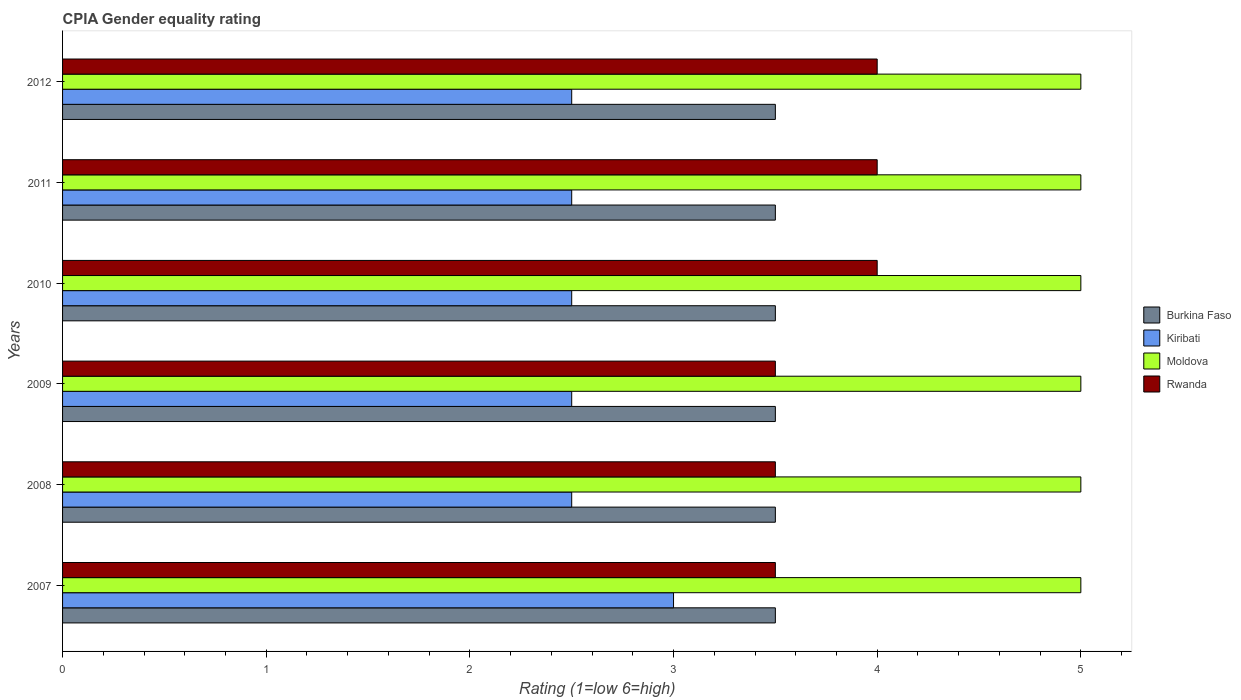How many different coloured bars are there?
Keep it short and to the point. 4. How many bars are there on the 1st tick from the top?
Offer a very short reply. 4. How many bars are there on the 5th tick from the bottom?
Make the answer very short. 4. What is the label of the 1st group of bars from the top?
Give a very brief answer. 2012. What is the CPIA rating in Burkina Faso in 2008?
Provide a short and direct response. 3.5. Across all years, what is the maximum CPIA rating in Kiribati?
Offer a very short reply. 3. Across all years, what is the minimum CPIA rating in Kiribati?
Make the answer very short. 2.5. In which year was the CPIA rating in Burkina Faso minimum?
Keep it short and to the point. 2007. What is the total CPIA rating in Rwanda in the graph?
Offer a very short reply. 22.5. What is the difference between the CPIA rating in Rwanda in 2009 and the CPIA rating in Burkina Faso in 2011?
Provide a short and direct response. 0. In the year 2007, what is the difference between the CPIA rating in Moldova and CPIA rating in Kiribati?
Your answer should be very brief. 2. In how many years, is the CPIA rating in Moldova greater than 3.2 ?
Your answer should be compact. 6. What is the ratio of the CPIA rating in Kiribati in 2009 to that in 2011?
Give a very brief answer. 1. What is the difference between the highest and the second highest CPIA rating in Rwanda?
Provide a short and direct response. 0. What is the difference between the highest and the lowest CPIA rating in Moldova?
Make the answer very short. 0. Is it the case that in every year, the sum of the CPIA rating in Burkina Faso and CPIA rating in Rwanda is greater than the sum of CPIA rating in Kiribati and CPIA rating in Moldova?
Your answer should be compact. Yes. What does the 4th bar from the top in 2012 represents?
Your answer should be compact. Burkina Faso. What does the 2nd bar from the bottom in 2012 represents?
Keep it short and to the point. Kiribati. How many years are there in the graph?
Make the answer very short. 6. Are the values on the major ticks of X-axis written in scientific E-notation?
Ensure brevity in your answer.  No. Does the graph contain any zero values?
Your answer should be very brief. No. How many legend labels are there?
Give a very brief answer. 4. What is the title of the graph?
Keep it short and to the point. CPIA Gender equality rating. What is the label or title of the Y-axis?
Keep it short and to the point. Years. What is the Rating (1=low 6=high) in Burkina Faso in 2007?
Give a very brief answer. 3.5. What is the Rating (1=low 6=high) in Moldova in 2007?
Your response must be concise. 5. What is the Rating (1=low 6=high) in Rwanda in 2007?
Offer a terse response. 3.5. What is the Rating (1=low 6=high) of Burkina Faso in 2008?
Provide a short and direct response. 3.5. What is the Rating (1=low 6=high) in Kiribati in 2008?
Provide a succinct answer. 2.5. What is the Rating (1=low 6=high) of Moldova in 2008?
Ensure brevity in your answer.  5. What is the Rating (1=low 6=high) in Rwanda in 2009?
Make the answer very short. 3.5. What is the Rating (1=low 6=high) in Burkina Faso in 2010?
Provide a short and direct response. 3.5. What is the Rating (1=low 6=high) of Kiribati in 2010?
Offer a very short reply. 2.5. What is the Rating (1=low 6=high) of Kiribati in 2011?
Your answer should be compact. 2.5. What is the Rating (1=low 6=high) of Rwanda in 2011?
Provide a succinct answer. 4. What is the Rating (1=low 6=high) of Burkina Faso in 2012?
Your answer should be compact. 3.5. What is the Rating (1=low 6=high) in Moldova in 2012?
Keep it short and to the point. 5. What is the Rating (1=low 6=high) of Rwanda in 2012?
Ensure brevity in your answer.  4. Across all years, what is the maximum Rating (1=low 6=high) in Moldova?
Your answer should be very brief. 5. Across all years, what is the minimum Rating (1=low 6=high) in Burkina Faso?
Your answer should be very brief. 3.5. Across all years, what is the minimum Rating (1=low 6=high) of Kiribati?
Provide a short and direct response. 2.5. Across all years, what is the minimum Rating (1=low 6=high) in Moldova?
Offer a terse response. 5. Across all years, what is the minimum Rating (1=low 6=high) in Rwanda?
Keep it short and to the point. 3.5. What is the total Rating (1=low 6=high) of Burkina Faso in the graph?
Offer a terse response. 21. What is the total Rating (1=low 6=high) in Rwanda in the graph?
Your response must be concise. 22.5. What is the difference between the Rating (1=low 6=high) in Kiribati in 2007 and that in 2008?
Provide a short and direct response. 0.5. What is the difference between the Rating (1=low 6=high) in Moldova in 2007 and that in 2008?
Offer a terse response. 0. What is the difference between the Rating (1=low 6=high) in Kiribati in 2007 and that in 2009?
Offer a terse response. 0.5. What is the difference between the Rating (1=low 6=high) of Moldova in 2007 and that in 2009?
Your answer should be compact. 0. What is the difference between the Rating (1=low 6=high) of Rwanda in 2007 and that in 2009?
Ensure brevity in your answer.  0. What is the difference between the Rating (1=low 6=high) of Kiribati in 2007 and that in 2010?
Offer a terse response. 0.5. What is the difference between the Rating (1=low 6=high) of Rwanda in 2007 and that in 2010?
Ensure brevity in your answer.  -0.5. What is the difference between the Rating (1=low 6=high) of Moldova in 2007 and that in 2011?
Make the answer very short. 0. What is the difference between the Rating (1=low 6=high) of Rwanda in 2007 and that in 2011?
Your response must be concise. -0.5. What is the difference between the Rating (1=low 6=high) in Moldova in 2007 and that in 2012?
Your answer should be compact. 0. What is the difference between the Rating (1=low 6=high) of Rwanda in 2008 and that in 2009?
Give a very brief answer. 0. What is the difference between the Rating (1=low 6=high) in Moldova in 2008 and that in 2010?
Your answer should be very brief. 0. What is the difference between the Rating (1=low 6=high) in Rwanda in 2008 and that in 2010?
Offer a terse response. -0.5. What is the difference between the Rating (1=low 6=high) in Kiribati in 2008 and that in 2011?
Ensure brevity in your answer.  0. What is the difference between the Rating (1=low 6=high) in Rwanda in 2008 and that in 2011?
Provide a succinct answer. -0.5. What is the difference between the Rating (1=low 6=high) in Burkina Faso in 2008 and that in 2012?
Provide a succinct answer. 0. What is the difference between the Rating (1=low 6=high) in Kiribati in 2008 and that in 2012?
Your answer should be compact. 0. What is the difference between the Rating (1=low 6=high) in Burkina Faso in 2009 and that in 2010?
Provide a succinct answer. 0. What is the difference between the Rating (1=low 6=high) in Kiribati in 2009 and that in 2010?
Make the answer very short. 0. What is the difference between the Rating (1=low 6=high) in Rwanda in 2009 and that in 2010?
Give a very brief answer. -0.5. What is the difference between the Rating (1=low 6=high) in Kiribati in 2009 and that in 2011?
Ensure brevity in your answer.  0. What is the difference between the Rating (1=low 6=high) in Rwanda in 2009 and that in 2011?
Ensure brevity in your answer.  -0.5. What is the difference between the Rating (1=low 6=high) of Burkina Faso in 2009 and that in 2012?
Offer a very short reply. 0. What is the difference between the Rating (1=low 6=high) of Moldova in 2009 and that in 2012?
Offer a very short reply. 0. What is the difference between the Rating (1=low 6=high) in Rwanda in 2009 and that in 2012?
Ensure brevity in your answer.  -0.5. What is the difference between the Rating (1=low 6=high) in Moldova in 2010 and that in 2011?
Give a very brief answer. 0. What is the difference between the Rating (1=low 6=high) of Burkina Faso in 2010 and that in 2012?
Offer a very short reply. 0. What is the difference between the Rating (1=low 6=high) in Moldova in 2010 and that in 2012?
Your answer should be compact. 0. What is the difference between the Rating (1=low 6=high) of Rwanda in 2010 and that in 2012?
Your answer should be compact. 0. What is the difference between the Rating (1=low 6=high) of Burkina Faso in 2011 and that in 2012?
Your response must be concise. 0. What is the difference between the Rating (1=low 6=high) in Kiribati in 2011 and that in 2012?
Make the answer very short. 0. What is the difference between the Rating (1=low 6=high) in Moldova in 2011 and that in 2012?
Give a very brief answer. 0. What is the difference between the Rating (1=low 6=high) in Rwanda in 2011 and that in 2012?
Provide a succinct answer. 0. What is the difference between the Rating (1=low 6=high) in Kiribati in 2007 and the Rating (1=low 6=high) in Moldova in 2008?
Your answer should be very brief. -2. What is the difference between the Rating (1=low 6=high) in Kiribati in 2007 and the Rating (1=low 6=high) in Rwanda in 2008?
Ensure brevity in your answer.  -0.5. What is the difference between the Rating (1=low 6=high) of Moldova in 2007 and the Rating (1=low 6=high) of Rwanda in 2008?
Your answer should be compact. 1.5. What is the difference between the Rating (1=low 6=high) in Burkina Faso in 2007 and the Rating (1=low 6=high) in Moldova in 2009?
Offer a very short reply. -1.5. What is the difference between the Rating (1=low 6=high) in Kiribati in 2007 and the Rating (1=low 6=high) in Moldova in 2009?
Offer a terse response. -2. What is the difference between the Rating (1=low 6=high) of Kiribati in 2007 and the Rating (1=low 6=high) of Rwanda in 2009?
Keep it short and to the point. -0.5. What is the difference between the Rating (1=low 6=high) of Burkina Faso in 2007 and the Rating (1=low 6=high) of Kiribati in 2010?
Offer a terse response. 1. What is the difference between the Rating (1=low 6=high) in Moldova in 2007 and the Rating (1=low 6=high) in Rwanda in 2010?
Offer a very short reply. 1. What is the difference between the Rating (1=low 6=high) of Burkina Faso in 2007 and the Rating (1=low 6=high) of Rwanda in 2011?
Give a very brief answer. -0.5. What is the difference between the Rating (1=low 6=high) in Kiribati in 2007 and the Rating (1=low 6=high) in Moldova in 2011?
Keep it short and to the point. -2. What is the difference between the Rating (1=low 6=high) in Moldova in 2007 and the Rating (1=low 6=high) in Rwanda in 2011?
Offer a very short reply. 1. What is the difference between the Rating (1=low 6=high) in Burkina Faso in 2007 and the Rating (1=low 6=high) in Rwanda in 2012?
Your answer should be compact. -0.5. What is the difference between the Rating (1=low 6=high) of Kiribati in 2007 and the Rating (1=low 6=high) of Rwanda in 2012?
Your answer should be compact. -1. What is the difference between the Rating (1=low 6=high) in Moldova in 2007 and the Rating (1=low 6=high) in Rwanda in 2012?
Provide a succinct answer. 1. What is the difference between the Rating (1=low 6=high) in Burkina Faso in 2008 and the Rating (1=low 6=high) in Rwanda in 2009?
Provide a succinct answer. 0. What is the difference between the Rating (1=low 6=high) in Kiribati in 2008 and the Rating (1=low 6=high) in Moldova in 2009?
Offer a terse response. -2.5. What is the difference between the Rating (1=low 6=high) in Burkina Faso in 2008 and the Rating (1=low 6=high) in Kiribati in 2010?
Give a very brief answer. 1. What is the difference between the Rating (1=low 6=high) of Burkina Faso in 2008 and the Rating (1=low 6=high) of Rwanda in 2010?
Keep it short and to the point. -0.5. What is the difference between the Rating (1=low 6=high) of Moldova in 2008 and the Rating (1=low 6=high) of Rwanda in 2010?
Ensure brevity in your answer.  1. What is the difference between the Rating (1=low 6=high) in Burkina Faso in 2008 and the Rating (1=low 6=high) in Kiribati in 2011?
Ensure brevity in your answer.  1. What is the difference between the Rating (1=low 6=high) of Burkina Faso in 2008 and the Rating (1=low 6=high) of Moldova in 2011?
Your response must be concise. -1.5. What is the difference between the Rating (1=low 6=high) in Kiribati in 2008 and the Rating (1=low 6=high) in Rwanda in 2011?
Your response must be concise. -1.5. What is the difference between the Rating (1=low 6=high) in Burkina Faso in 2008 and the Rating (1=low 6=high) in Rwanda in 2012?
Ensure brevity in your answer.  -0.5. What is the difference between the Rating (1=low 6=high) of Moldova in 2008 and the Rating (1=low 6=high) of Rwanda in 2012?
Keep it short and to the point. 1. What is the difference between the Rating (1=low 6=high) of Burkina Faso in 2009 and the Rating (1=low 6=high) of Moldova in 2010?
Ensure brevity in your answer.  -1.5. What is the difference between the Rating (1=low 6=high) in Kiribati in 2009 and the Rating (1=low 6=high) in Rwanda in 2010?
Ensure brevity in your answer.  -1.5. What is the difference between the Rating (1=low 6=high) of Burkina Faso in 2009 and the Rating (1=low 6=high) of Kiribati in 2011?
Offer a terse response. 1. What is the difference between the Rating (1=low 6=high) of Burkina Faso in 2009 and the Rating (1=low 6=high) of Moldova in 2011?
Provide a short and direct response. -1.5. What is the difference between the Rating (1=low 6=high) of Burkina Faso in 2009 and the Rating (1=low 6=high) of Rwanda in 2011?
Your response must be concise. -0.5. What is the difference between the Rating (1=low 6=high) in Kiribati in 2009 and the Rating (1=low 6=high) in Moldova in 2011?
Offer a terse response. -2.5. What is the difference between the Rating (1=low 6=high) of Burkina Faso in 2009 and the Rating (1=low 6=high) of Kiribati in 2012?
Give a very brief answer. 1. What is the difference between the Rating (1=low 6=high) of Burkina Faso in 2009 and the Rating (1=low 6=high) of Rwanda in 2012?
Ensure brevity in your answer.  -0.5. What is the difference between the Rating (1=low 6=high) of Kiribati in 2009 and the Rating (1=low 6=high) of Moldova in 2012?
Your answer should be very brief. -2.5. What is the difference between the Rating (1=low 6=high) of Moldova in 2009 and the Rating (1=low 6=high) of Rwanda in 2012?
Keep it short and to the point. 1. What is the difference between the Rating (1=low 6=high) in Burkina Faso in 2010 and the Rating (1=low 6=high) in Rwanda in 2011?
Offer a terse response. -0.5. What is the difference between the Rating (1=low 6=high) in Kiribati in 2010 and the Rating (1=low 6=high) in Moldova in 2011?
Your response must be concise. -2.5. What is the difference between the Rating (1=low 6=high) of Kiribati in 2010 and the Rating (1=low 6=high) of Rwanda in 2011?
Give a very brief answer. -1.5. What is the difference between the Rating (1=low 6=high) of Moldova in 2010 and the Rating (1=low 6=high) of Rwanda in 2011?
Provide a succinct answer. 1. What is the difference between the Rating (1=low 6=high) in Kiribati in 2010 and the Rating (1=low 6=high) in Moldova in 2012?
Ensure brevity in your answer.  -2.5. What is the difference between the Rating (1=low 6=high) of Kiribati in 2010 and the Rating (1=low 6=high) of Rwanda in 2012?
Offer a very short reply. -1.5. What is the difference between the Rating (1=low 6=high) in Burkina Faso in 2011 and the Rating (1=low 6=high) in Kiribati in 2012?
Keep it short and to the point. 1. What is the difference between the Rating (1=low 6=high) of Burkina Faso in 2011 and the Rating (1=low 6=high) of Rwanda in 2012?
Give a very brief answer. -0.5. What is the difference between the Rating (1=low 6=high) of Kiribati in 2011 and the Rating (1=low 6=high) of Moldova in 2012?
Your answer should be compact. -2.5. What is the average Rating (1=low 6=high) of Burkina Faso per year?
Your answer should be very brief. 3.5. What is the average Rating (1=low 6=high) in Kiribati per year?
Provide a succinct answer. 2.58. What is the average Rating (1=low 6=high) of Rwanda per year?
Give a very brief answer. 3.75. In the year 2007, what is the difference between the Rating (1=low 6=high) in Burkina Faso and Rating (1=low 6=high) in Kiribati?
Your response must be concise. 0.5. In the year 2007, what is the difference between the Rating (1=low 6=high) of Burkina Faso and Rating (1=low 6=high) of Moldova?
Keep it short and to the point. -1.5. In the year 2007, what is the difference between the Rating (1=low 6=high) of Burkina Faso and Rating (1=low 6=high) of Rwanda?
Ensure brevity in your answer.  0. In the year 2007, what is the difference between the Rating (1=low 6=high) of Kiribati and Rating (1=low 6=high) of Moldova?
Offer a very short reply. -2. In the year 2007, what is the difference between the Rating (1=low 6=high) of Moldova and Rating (1=low 6=high) of Rwanda?
Offer a terse response. 1.5. In the year 2008, what is the difference between the Rating (1=low 6=high) in Burkina Faso and Rating (1=low 6=high) in Rwanda?
Your answer should be compact. 0. In the year 2008, what is the difference between the Rating (1=low 6=high) of Kiribati and Rating (1=low 6=high) of Moldova?
Your answer should be very brief. -2.5. In the year 2008, what is the difference between the Rating (1=low 6=high) in Moldova and Rating (1=low 6=high) in Rwanda?
Offer a terse response. 1.5. In the year 2009, what is the difference between the Rating (1=low 6=high) in Burkina Faso and Rating (1=low 6=high) in Kiribati?
Provide a succinct answer. 1. In the year 2009, what is the difference between the Rating (1=low 6=high) in Burkina Faso and Rating (1=low 6=high) in Moldova?
Make the answer very short. -1.5. In the year 2009, what is the difference between the Rating (1=low 6=high) in Kiribati and Rating (1=low 6=high) in Moldova?
Give a very brief answer. -2.5. In the year 2009, what is the difference between the Rating (1=low 6=high) of Kiribati and Rating (1=low 6=high) of Rwanda?
Make the answer very short. -1. In the year 2009, what is the difference between the Rating (1=low 6=high) in Moldova and Rating (1=low 6=high) in Rwanda?
Keep it short and to the point. 1.5. In the year 2010, what is the difference between the Rating (1=low 6=high) in Burkina Faso and Rating (1=low 6=high) in Rwanda?
Give a very brief answer. -0.5. In the year 2010, what is the difference between the Rating (1=low 6=high) in Kiribati and Rating (1=low 6=high) in Rwanda?
Provide a short and direct response. -1.5. In the year 2010, what is the difference between the Rating (1=low 6=high) of Moldova and Rating (1=low 6=high) of Rwanda?
Offer a terse response. 1. In the year 2011, what is the difference between the Rating (1=low 6=high) in Burkina Faso and Rating (1=low 6=high) in Kiribati?
Make the answer very short. 1. In the year 2011, what is the difference between the Rating (1=low 6=high) in Burkina Faso and Rating (1=low 6=high) in Rwanda?
Offer a very short reply. -0.5. In the year 2011, what is the difference between the Rating (1=low 6=high) in Kiribati and Rating (1=low 6=high) in Rwanda?
Your answer should be compact. -1.5. In the year 2012, what is the difference between the Rating (1=low 6=high) of Burkina Faso and Rating (1=low 6=high) of Moldova?
Make the answer very short. -1.5. In the year 2012, what is the difference between the Rating (1=low 6=high) of Burkina Faso and Rating (1=low 6=high) of Rwanda?
Ensure brevity in your answer.  -0.5. In the year 2012, what is the difference between the Rating (1=low 6=high) of Moldova and Rating (1=low 6=high) of Rwanda?
Your response must be concise. 1. What is the ratio of the Rating (1=low 6=high) in Moldova in 2007 to that in 2008?
Offer a terse response. 1. What is the ratio of the Rating (1=low 6=high) in Rwanda in 2007 to that in 2008?
Give a very brief answer. 1. What is the ratio of the Rating (1=low 6=high) in Burkina Faso in 2007 to that in 2009?
Keep it short and to the point. 1. What is the ratio of the Rating (1=low 6=high) of Kiribati in 2007 to that in 2009?
Ensure brevity in your answer.  1.2. What is the ratio of the Rating (1=low 6=high) of Kiribati in 2007 to that in 2010?
Give a very brief answer. 1.2. What is the ratio of the Rating (1=low 6=high) of Moldova in 2007 to that in 2010?
Offer a very short reply. 1. What is the ratio of the Rating (1=low 6=high) of Rwanda in 2007 to that in 2010?
Offer a terse response. 0.88. What is the ratio of the Rating (1=low 6=high) in Moldova in 2007 to that in 2011?
Your answer should be compact. 1. What is the ratio of the Rating (1=low 6=high) in Rwanda in 2007 to that in 2011?
Provide a succinct answer. 0.88. What is the ratio of the Rating (1=low 6=high) of Kiribati in 2007 to that in 2012?
Your response must be concise. 1.2. What is the ratio of the Rating (1=low 6=high) in Moldova in 2007 to that in 2012?
Your answer should be compact. 1. What is the ratio of the Rating (1=low 6=high) in Burkina Faso in 2008 to that in 2009?
Ensure brevity in your answer.  1. What is the ratio of the Rating (1=low 6=high) in Kiribati in 2008 to that in 2009?
Provide a succinct answer. 1. What is the ratio of the Rating (1=low 6=high) of Moldova in 2008 to that in 2009?
Provide a succinct answer. 1. What is the ratio of the Rating (1=low 6=high) of Burkina Faso in 2008 to that in 2010?
Your answer should be very brief. 1. What is the ratio of the Rating (1=low 6=high) of Moldova in 2008 to that in 2010?
Make the answer very short. 1. What is the ratio of the Rating (1=low 6=high) in Rwanda in 2008 to that in 2010?
Make the answer very short. 0.88. What is the ratio of the Rating (1=low 6=high) of Kiribati in 2008 to that in 2011?
Provide a short and direct response. 1. What is the ratio of the Rating (1=low 6=high) of Moldova in 2008 to that in 2011?
Provide a short and direct response. 1. What is the ratio of the Rating (1=low 6=high) of Kiribati in 2008 to that in 2012?
Provide a short and direct response. 1. What is the ratio of the Rating (1=low 6=high) of Moldova in 2009 to that in 2010?
Keep it short and to the point. 1. What is the ratio of the Rating (1=low 6=high) in Rwanda in 2009 to that in 2011?
Offer a very short reply. 0.88. What is the ratio of the Rating (1=low 6=high) in Burkina Faso in 2009 to that in 2012?
Provide a short and direct response. 1. What is the ratio of the Rating (1=low 6=high) of Moldova in 2009 to that in 2012?
Provide a short and direct response. 1. What is the ratio of the Rating (1=low 6=high) of Rwanda in 2009 to that in 2012?
Provide a succinct answer. 0.88. What is the ratio of the Rating (1=low 6=high) of Rwanda in 2010 to that in 2012?
Give a very brief answer. 1. What is the ratio of the Rating (1=low 6=high) in Burkina Faso in 2011 to that in 2012?
Provide a short and direct response. 1. What is the ratio of the Rating (1=low 6=high) in Rwanda in 2011 to that in 2012?
Provide a short and direct response. 1. What is the difference between the highest and the second highest Rating (1=low 6=high) of Burkina Faso?
Your answer should be compact. 0. What is the difference between the highest and the second highest Rating (1=low 6=high) in Kiribati?
Offer a terse response. 0.5. What is the difference between the highest and the second highest Rating (1=low 6=high) of Rwanda?
Your answer should be very brief. 0. What is the difference between the highest and the lowest Rating (1=low 6=high) in Burkina Faso?
Your answer should be very brief. 0. What is the difference between the highest and the lowest Rating (1=low 6=high) of Kiribati?
Give a very brief answer. 0.5. What is the difference between the highest and the lowest Rating (1=low 6=high) of Moldova?
Your answer should be compact. 0. 